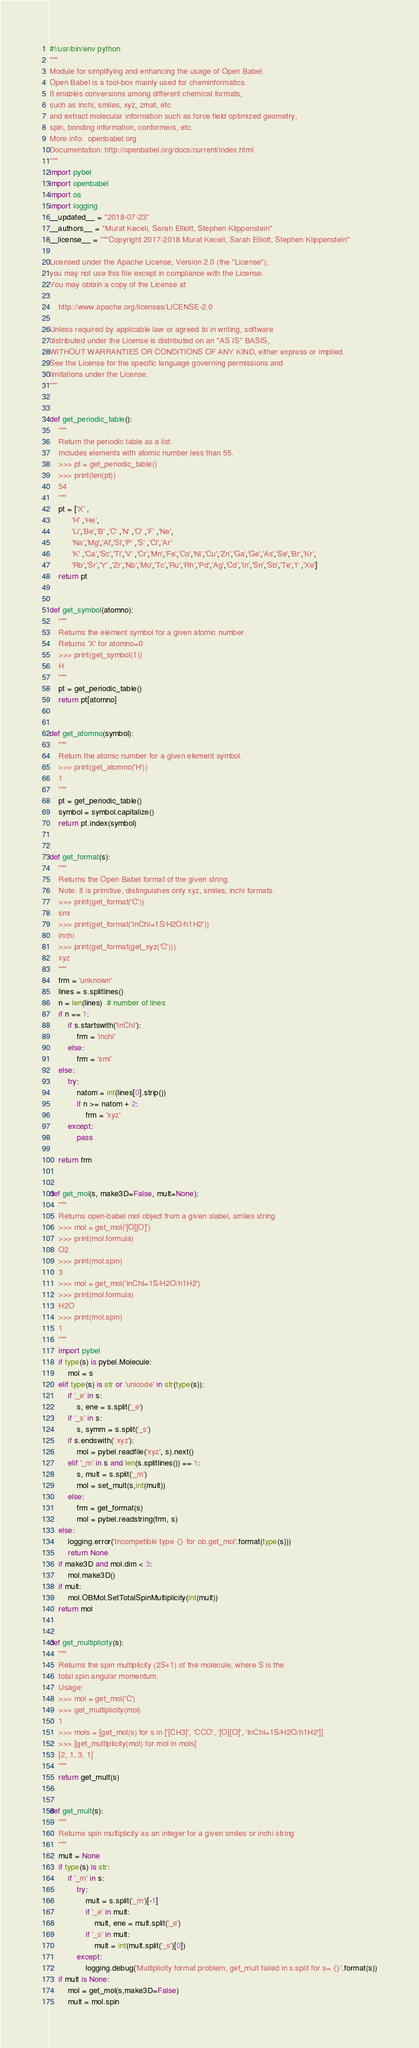<code> <loc_0><loc_0><loc_500><loc_500><_Python_>#!/usr/bin/env python
"""
Module for simplifying and enhancing the usage of Open Babel.
Open Babel is a tool-box mainly used for cheminformatics.
It enables conversions among different chemical formats,
such as inchi, smiles, xyz, zmat, etc
and extract molecular information such as force field optimized geometry,
spin, bonding information, conformers, etc.
More info:  openbabel.org
Documentation: http://openbabel.org/docs/current/index.html
"""
import pybel
import openbabel
import os
import logging
__updated__ = "2018-07-23"
__authors__ = "Murat Keceli, Sarah Elliott, Stephen Klippenstein"
__license__ = """Copyright 2017-2018 Murat Keceli, Sarah Elliott, Stephen Klippenstein"

Licensed under the Apache License, Version 2.0 (the "License");
you may not use this file except in compliance with the License.
You may obtain a copy of the License at

    http://www.apache.org/licenses/LICENSE-2.0

Unless required by applicable law or agreed to in writing, software
distributed under the License is distributed on an "AS IS" BASIS,
WITHOUT WARRANTIES OR CONDITIONS OF ANY KIND, either express or implied.
See the License for the specific language governing permissions and
limitations under the License.
"""


def get_periodic_table():
    """
    Return the periodic table as a list.
    Includes elements with atomic number less than 55.
    >>> pt = get_periodic_table()
    >>> print(len(pt))
    54
    """
    pt = ['X' ,
          'H' ,'He',
          'Li','Be','B' ,'C' ,'N' ,'O' ,'F' ,'Ne',
          'Na','Mg','Al','Si','P' ,'S' ,'Cl','Ar'
          'K' ,'Ca','Sc','Ti','V' ,'Cr','Mn','Fe','Co','Ni','Cu','Zn','Ga','Ge','As','Se','Br','Kr',
          'Rb','Sr','Y' ,'Zr','Nb','Mo','Tc','Ru','Rh','Pd','Ag','Cd','In','Sn','Sb','Te','I' ,'Xe']
    return pt


def get_symbol(atomno):
    """
    Returns the element symbol for a given atomic number.
    Returns 'X' for atomno=0
    >>> print(get_symbol(1))
    H
    """
    pt = get_periodic_table()
    return pt[atomno]


def get_atomno(symbol):
    """
    Return the atomic number for a given element symbol.
    >>> print(get_atomno('H'))
    1
    """
    pt = get_periodic_table()
    symbol = symbol.capitalize()
    return pt.index(symbol)


def get_format(s):
    """
    Returns the Open Babel format of the given string.
    Note: It is primitive, distinguishes only xyz, smiles, inchi formats.
    >>> print(get_format('C'))
    smi
    >>> print(get_format('InChI=1S/H2O/h1H2'))
    inchi
    >>> print(get_format(get_xyz('C')))
    xyz
    """
    frm = 'unknown'
    lines = s.splitlines()
    n = len(lines)  # number of lines
    if n == 1:
        if s.startswith('InChI'):
            frm = 'inchi'
        else:
            frm = 'smi'
    else:
        try:
            natom = int(lines[0].strip())
            if n >= natom + 2:
                frm = 'xyz'
        except:
            pass

    return frm


def get_mol(s, make3D=False, mult=None):
    """
    Returns open-babel mol object from a given slabel, smiles string 
    >>> mol = get_mol('[O][O]')
    >>> print(mol.formula)
    O2
    >>> print(mol.spin)
    3
    >>> mol = get_mol('InChI=1S/H2O/h1H2')
    >>> print(mol.formula)
    H2O
    >>> print(mol.spin)
    1
    """
    import pybel
    if type(s) is pybel.Molecule:
        mol = s
    elif type(s) is str or 'unicode' in str(type(s)):
        if '_e' in s:
            s, ene = s.split('_e')
        if '_s' in s:
            s, symm = s.split('_s')
        if s.endswith('.xyz'):
            mol = pybel.readfile('xyz', s).next()
        elif '_m' in s and len(s.splitlines()) == 1:
            s, mult = s.split('_m')
            mol = set_mult(s,int(mult))
        else:
            frm = get_format(s)
            mol = pybel.readstring(frm, s)
    else:
        logging.error('Incompetible type {} for ob.get_mol'.format(type(s)))
        return None
    if make3D and mol.dim < 3:
        mol.make3D()
    if mult:
        mol.OBMol.SetTotalSpinMultiplicity(int(mult))
    return mol
    
    
def get_multiplicity(s):
    """
    Returns the spin multiplicity (2S+1) of the molecule, where S is the
    total spin angular momentum.
    Usage:
    >>> mol = get_mol('C')
    >>> get_multiplicity(mol)
    1
    >>> mols = [get_mol(s) for s in ['[CH3]', 'CCO', '[O][O]', 'InChI=1S/H2O/h1H2']]
    >>> [get_multiplicity(mol) for mol in mols]
    [2, 1, 3, 1]
    """
    return get_mult(s)


def get_mult(s):
    """
    Returns spin multiplicity as an integer for a given smiles or inchi string
    """
    mult = None
    if type(s) is str:
        if '_m' in s:
            try:
                mult = s.split('_m')[-1]
                if '_e' in mult:
                    mult, ene = mult.split('_e')
                if '_s' in mult:
                    mult = int(mult.split('_s')[0])
            except:
                logging.debug('Multiplicity format problem, get_mult failed in s.split for s= {}'.format(s))
    if mult is None:
        mol = get_mol(s,make3D=False)
        mult = mol.spin</code> 